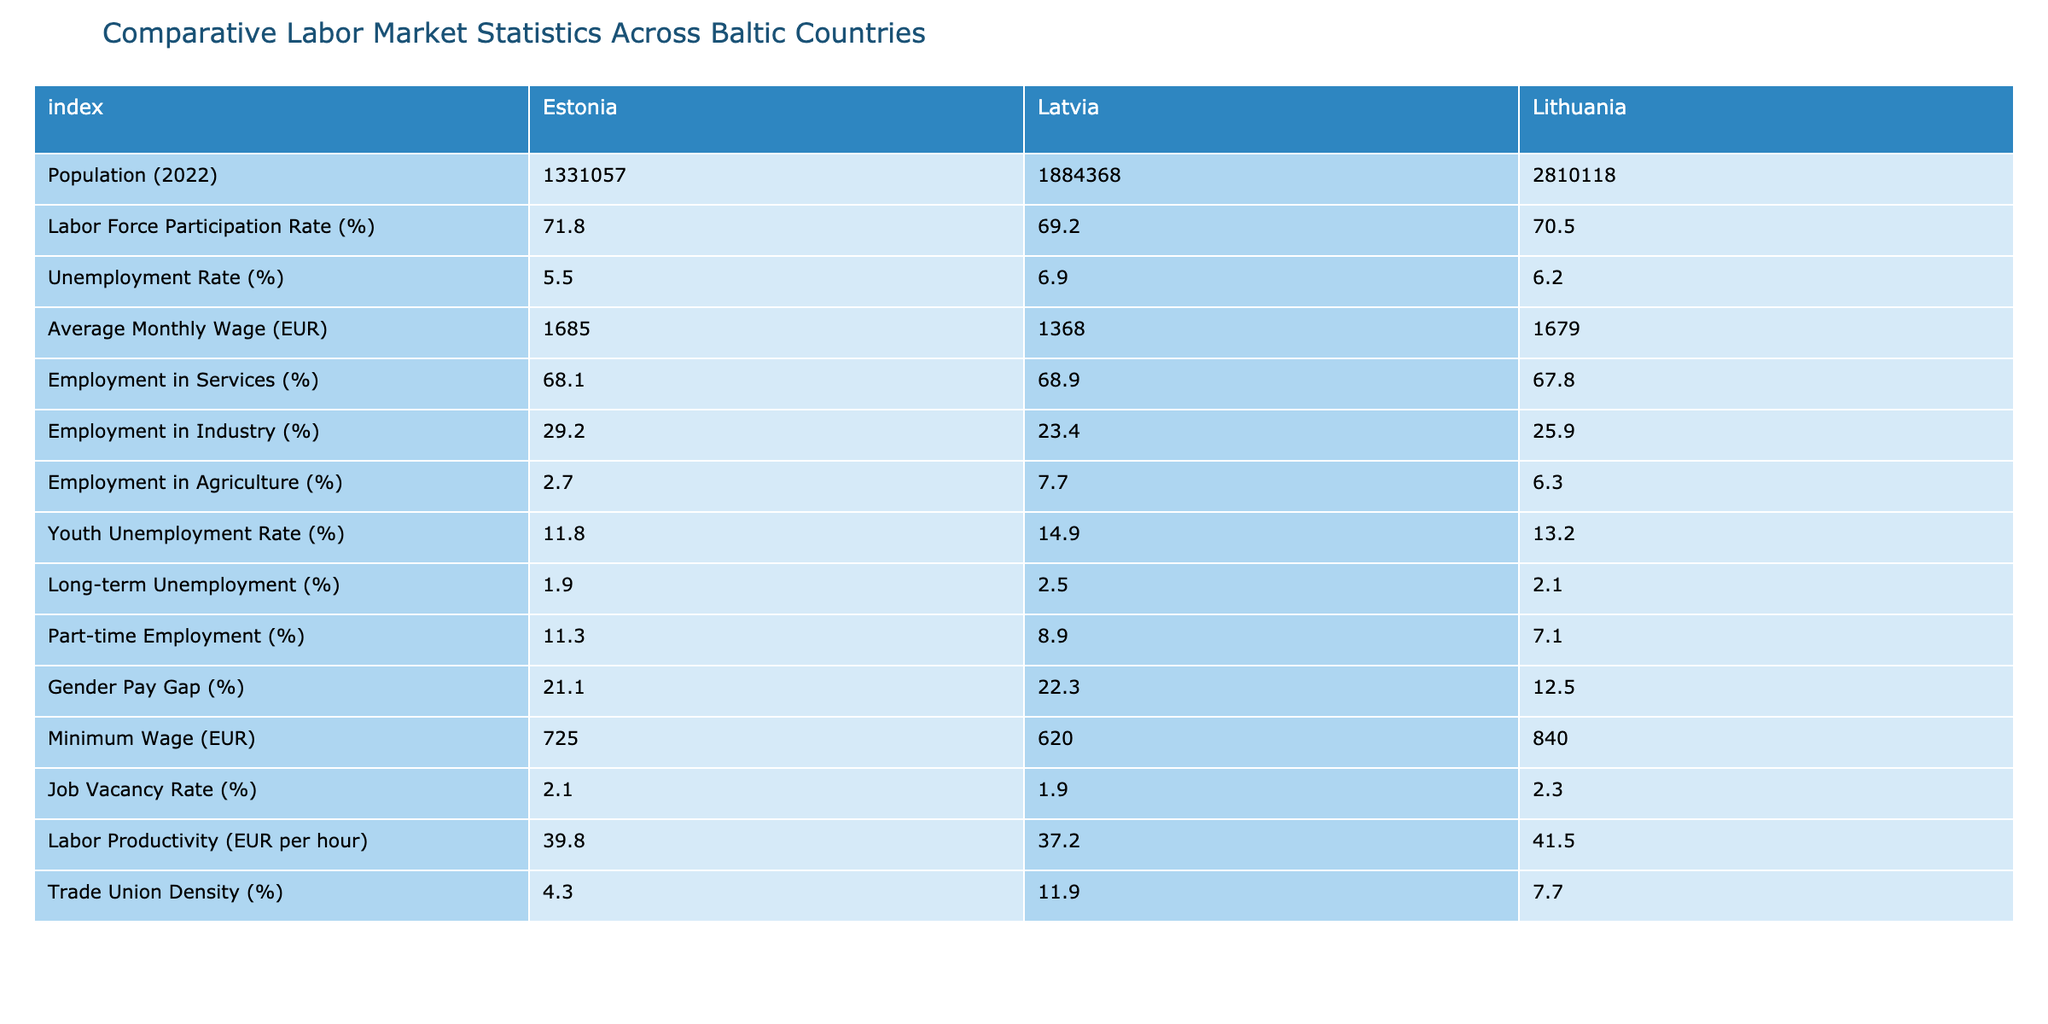What is the unemployment rate in Estonia? The table shows that the unemployment rate in Estonia is listed as 5.5%.
Answer: 5.5% Which country has the highest average monthly wage? By comparing the average monthly wage values in the table, Estonia has an average of 1685 EUR, while Lithuania has 1679 EUR, and Latvia has 1368 EUR. Estonia's average wage is the highest.
Answer: Estonia What is the labor force participation rate in Latvia? The labor force participation rate for Latvia, as shown in the table, is 69.2%.
Answer: 69.2% Calculate the difference in minimum wage between Estonia and Latvia. Estonia's minimum wage is 725 EUR and Latvia's minimum wage is 620 EUR. The difference is 725 - 620 = 105 EUR.
Answer: 105 EUR Is the youth unemployment rate higher in Lithuania than in Estonia? The youth unemployment rate in Lithuania is 13.2%, while in Estonia it is 11.8%. Since 13.2% > 11.8%, the statement is true.
Answer: Yes What is the average unemployment rate across the three countries? The unemployment rates are 5.5% (Estonia), 6.9% (Latvia), and 6.2% (Lithuania). To calculate the average, sum them: 5.5 + 6.9 + 6.2 = 18.6, then divide by 3: 18.6 / 3 = 6.2%.
Answer: 6.2% Which country has the lowest trade union density? The trade union density percentages are 4.3% (Estonia), 11.9% (Latvia), and 7.7% (Lithuania). Estonia has the lowest percentage at 4.3%.
Answer: Estonia If we observe the employment in agriculture, which country has the highest percentage? The table lists employment in agriculture as 2.7% (Estonia), 7.7% (Latvia), and 6.3% (Lithuania). Latvia has the highest percentage at 7.7%.
Answer: Latvia What percentage of Estonia's labor force is employed in services? According to the table, 68.1% of Estonia's labor force is employed in services.
Answer: 68.1% Compare the part-time employment rates between Estonia and Lithuania. Estonia's part-time employment rate is 11.3%, while Lithuania's is 7.1%. Since 11.3% > 7.1%, Estonia has a higher part-time employment rate.
Answer: Estonia What is the ratio of the average monthly wage in Lithuania to that in Latvia? The average monthly wage in Lithuania is 1679 EUR and in Latvia it is 1368 EUR. The ratio is 1679 / 1368 ≈ 1.23.
Answer: 1.23 